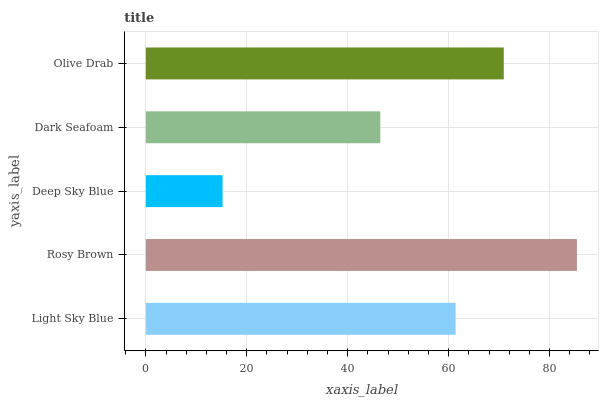Is Deep Sky Blue the minimum?
Answer yes or no. Yes. Is Rosy Brown the maximum?
Answer yes or no. Yes. Is Rosy Brown the minimum?
Answer yes or no. No. Is Deep Sky Blue the maximum?
Answer yes or no. No. Is Rosy Brown greater than Deep Sky Blue?
Answer yes or no. Yes. Is Deep Sky Blue less than Rosy Brown?
Answer yes or no. Yes. Is Deep Sky Blue greater than Rosy Brown?
Answer yes or no. No. Is Rosy Brown less than Deep Sky Blue?
Answer yes or no. No. Is Light Sky Blue the high median?
Answer yes or no. Yes. Is Light Sky Blue the low median?
Answer yes or no. Yes. Is Deep Sky Blue the high median?
Answer yes or no. No. Is Rosy Brown the low median?
Answer yes or no. No. 